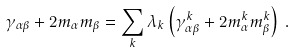<formula> <loc_0><loc_0><loc_500><loc_500>\gamma _ { \alpha \beta } + 2 m _ { \alpha } m _ { \beta } = \sum _ { k } \lambda _ { k } \left ( \gamma ^ { k } _ { \alpha \beta } + 2 m ^ { k } _ { \alpha } m ^ { k } _ { \beta } \right ) \, .</formula> 